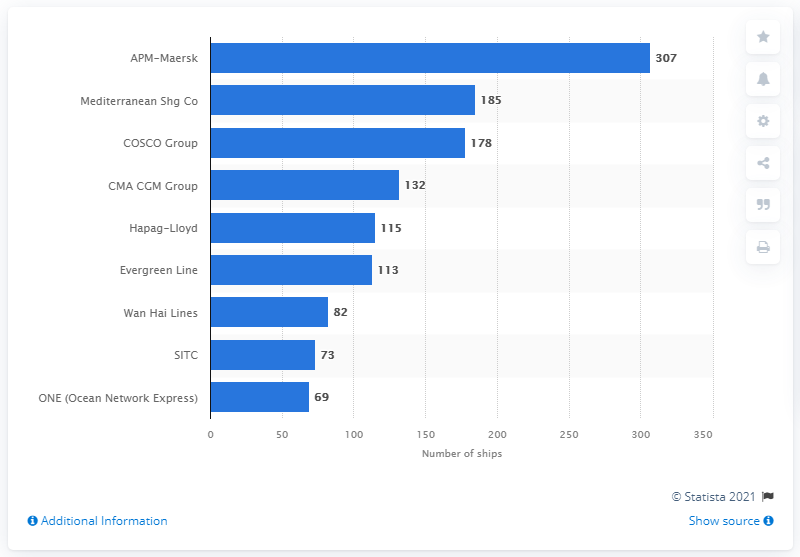Indicate a few pertinent items in this graphic. Mediterranean Shipping Company had 185 ships at its disposal. As of June 21, 2021, APM-Maersk had a total of 307 ships. 